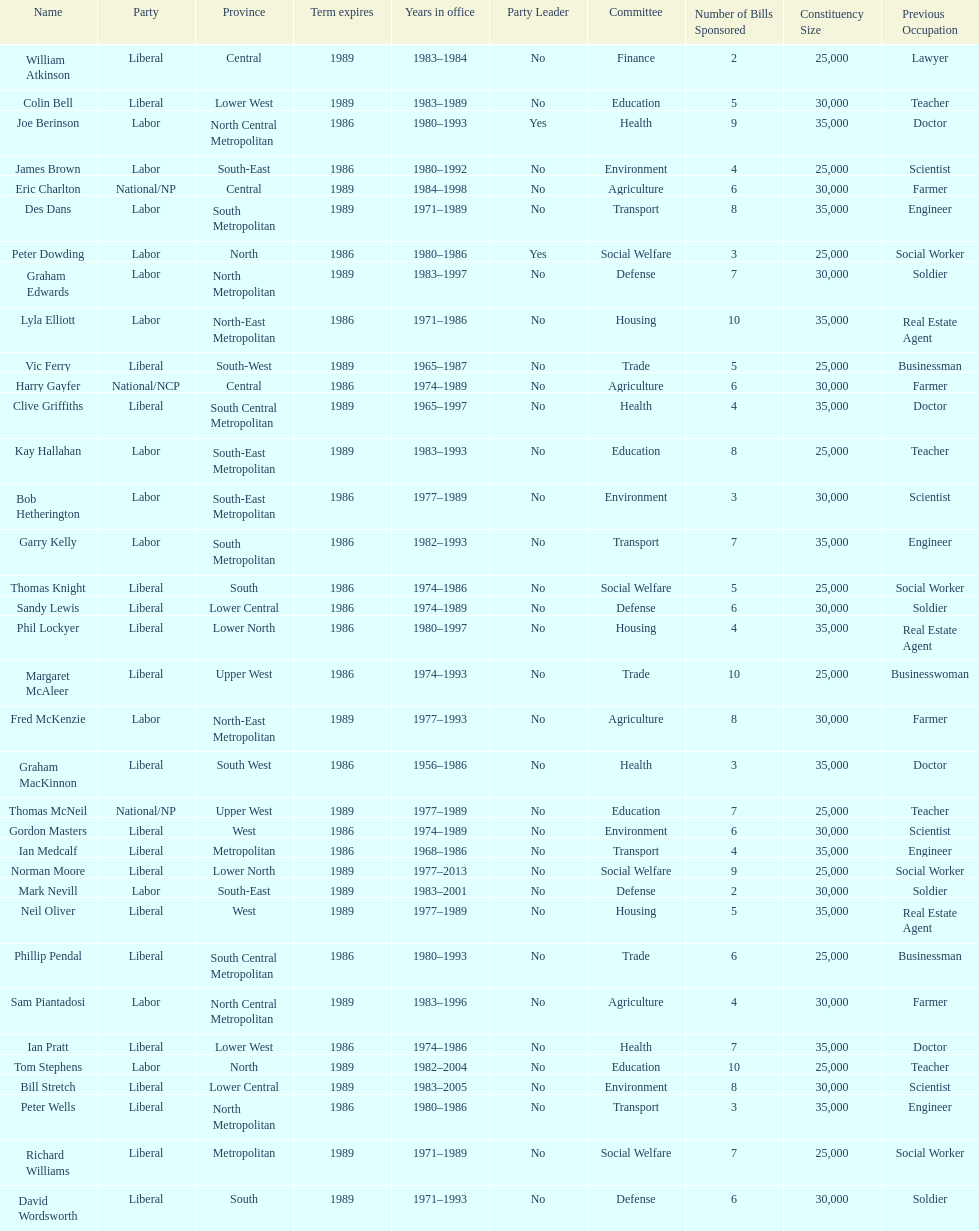Which party has the most membership? Liberal. 